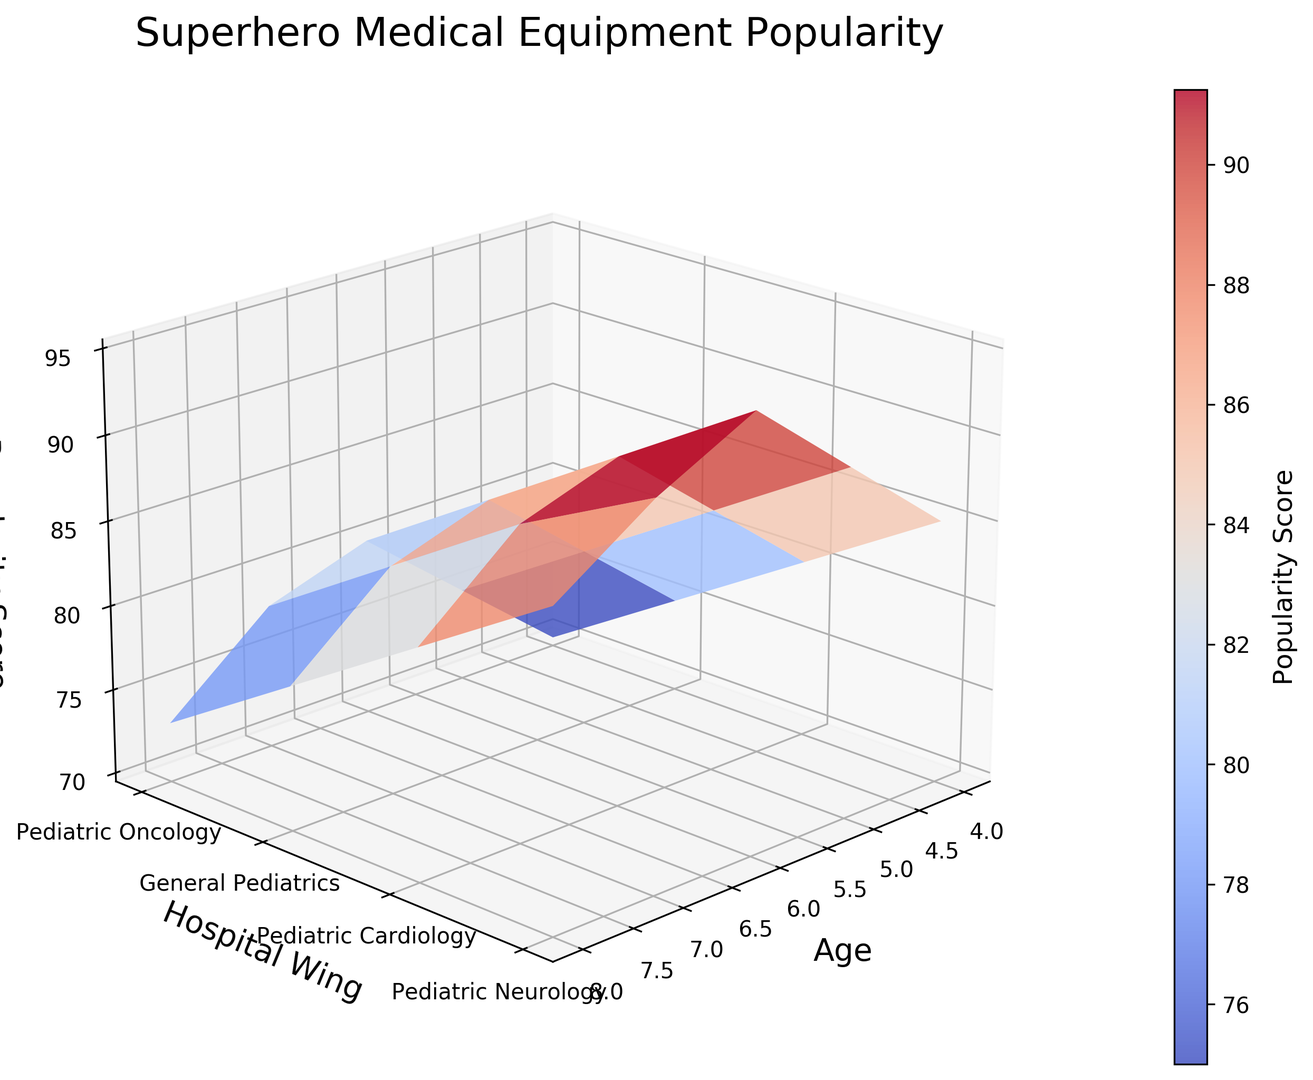Which age group has the highest overall popularity score across all hospital wings? By observing the height of the points on the surface plot, the 6-year-old age group has the highest overall popularity scores, showing the tallest columns.
Answer: 6-year-olds Which hospital wing consistently shows high popularity scores for all age groups? By looking across the surface plot, Pediatric Oncology has high peaks for every age group, indicating consistently high popularity scores.
Answer: Pediatric Oncology Which age group has the lowest popularity score in the General Pediatrics wing? By looking at the height of the columns for the General Pediatrics wing, the 8-year-olds have the smallest column, indicating the lowest popularity score.
Answer: 8-year-olds What is the average popularity score for Pediatric Neurology for all age groups? The scores are 80, 85, 90, 88, and 83. Sum these values: 80 + 85 + 90 + 88 + 83 = 426. Then, divide by the number of age groups 426 / 5 = 85.2.
Answer: 85.2 Compare the popularity score of 5-year-olds in Pediatric Cardiology with 6-year-olds in General Pediatrics. Which is higher? The popularity score for 5-year-olds in Pediatric Cardiology is 80, and for 6-year-olds in General Pediatrics, it is 80. Both scores are the same.
Answer: Equal Does any hospital wing have a consistently decreasing trend in popularity scores as age increases? By looking at the heights of the columns for each wing from left to right, none show a clear decreasing trend.
Answer: No What is the difference in popularity score between the highest and lowest scores for 4-year-olds? The scores for 4-year-olds are 85 (highest) and 70 (lowest). The difference is 85 - 70 = 15.
Answer: 15 Identify one age group and hospital wing pair that shows exceptional popularity scores compared to their neighboring pairs. The 6-year-olds in Pediatric Oncology show a significantly high column, with the highest popularity score of 95.
Answer: 6-year-olds in Pediatric Oncology What is the sum of popularity scores for 7-year-olds across all hospital wings? The scores for 7-year-olds are 92, 78, 83, and 88. Summing these gives: 92 + 78 + 83 + 88 = 341.
Answer: 341 How does the color change indicate popularity score levels? The plot uses a 'coolwarm' color map where warmer colors (red) represent higher popularity scores, and cooler colors (blue) represent lower scores.
Answer: Warm colors for high scores and cool colors for low scores 